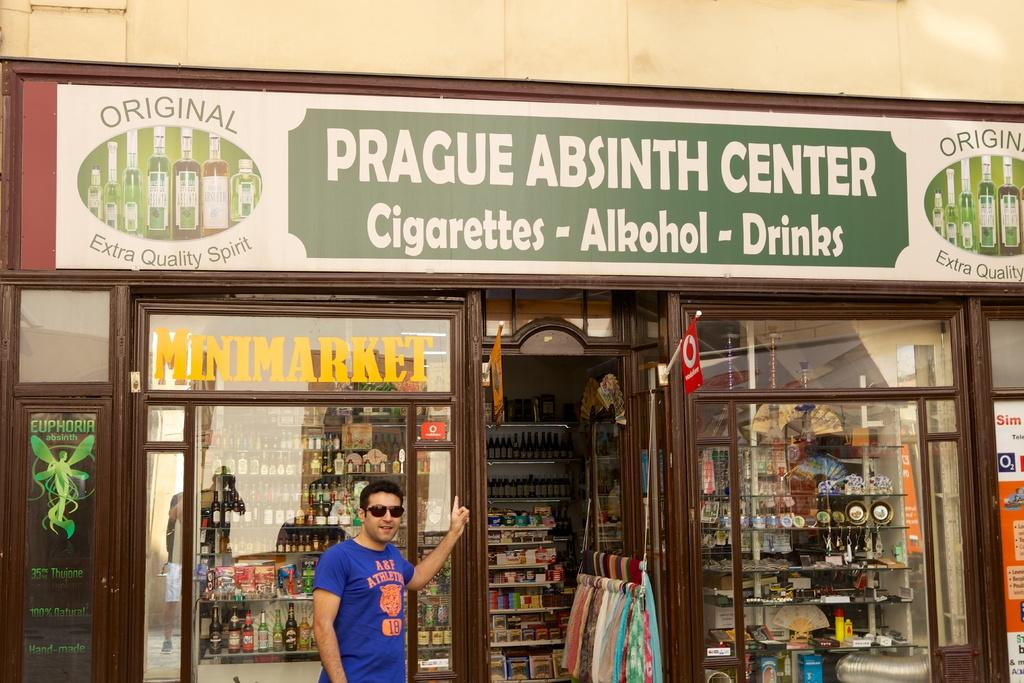<image>
Provide a brief description of the given image. the word Prague is on the sign above the ground 